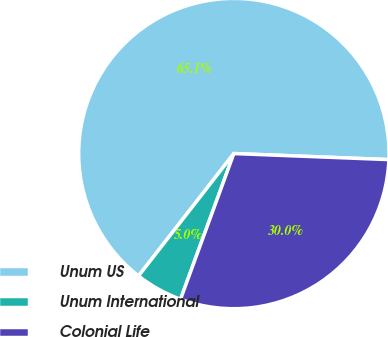Convert chart. <chart><loc_0><loc_0><loc_500><loc_500><pie_chart><fcel>Unum US<fcel>Unum International<fcel>Colonial Life<nl><fcel>65.09%<fcel>4.95%<fcel>29.96%<nl></chart> 